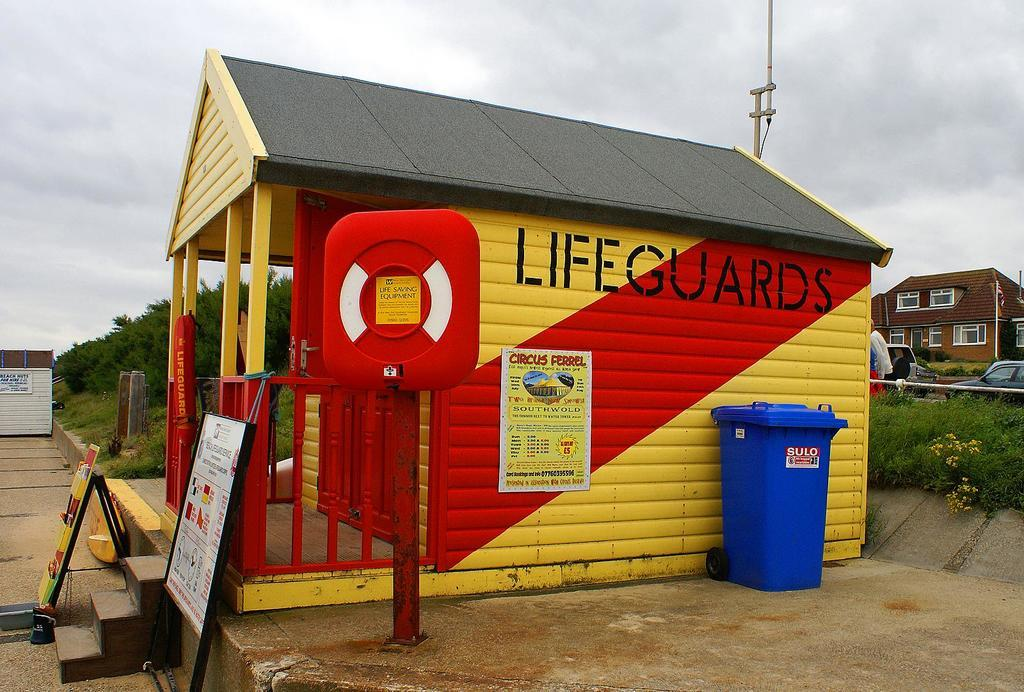Provide a one-sentence caption for the provided image. A lifeguards' shack has a red diagonal stripe on the side. 